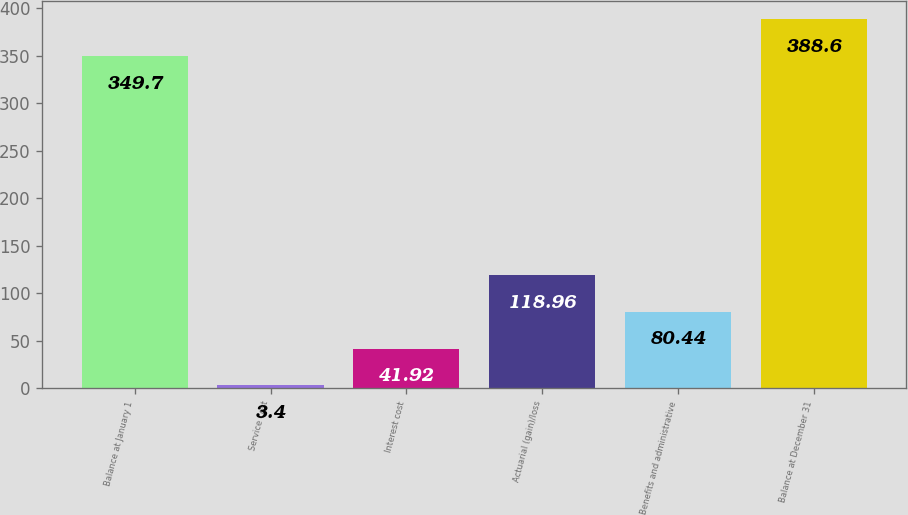Convert chart. <chart><loc_0><loc_0><loc_500><loc_500><bar_chart><fcel>Balance at January 1<fcel>Service cost<fcel>Interest cost<fcel>Actuarial (gain)/loss<fcel>Benefits and administrative<fcel>Balance at December 31<nl><fcel>349.7<fcel>3.4<fcel>41.92<fcel>118.96<fcel>80.44<fcel>388.6<nl></chart> 